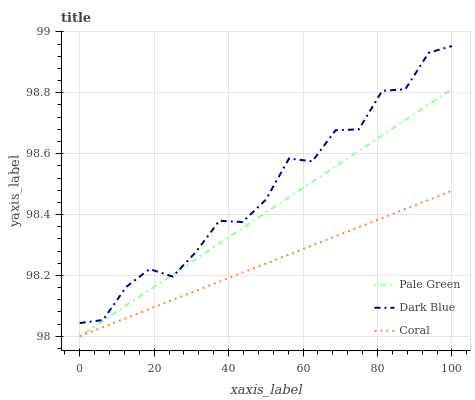Does Coral have the minimum area under the curve?
Answer yes or no. Yes. Does Dark Blue have the maximum area under the curve?
Answer yes or no. Yes. Does Pale Green have the minimum area under the curve?
Answer yes or no. No. Does Pale Green have the maximum area under the curve?
Answer yes or no. No. Is Coral the smoothest?
Answer yes or no. Yes. Is Dark Blue the roughest?
Answer yes or no. Yes. Is Pale Green the smoothest?
Answer yes or no. No. Is Pale Green the roughest?
Answer yes or no. No. Does Coral have the lowest value?
Answer yes or no. Yes. Does Dark Blue have the highest value?
Answer yes or no. Yes. Does Pale Green have the highest value?
Answer yes or no. No. Is Coral less than Dark Blue?
Answer yes or no. Yes. Is Dark Blue greater than Coral?
Answer yes or no. Yes. Does Pale Green intersect Dark Blue?
Answer yes or no. Yes. Is Pale Green less than Dark Blue?
Answer yes or no. No. Is Pale Green greater than Dark Blue?
Answer yes or no. No. Does Coral intersect Dark Blue?
Answer yes or no. No. 